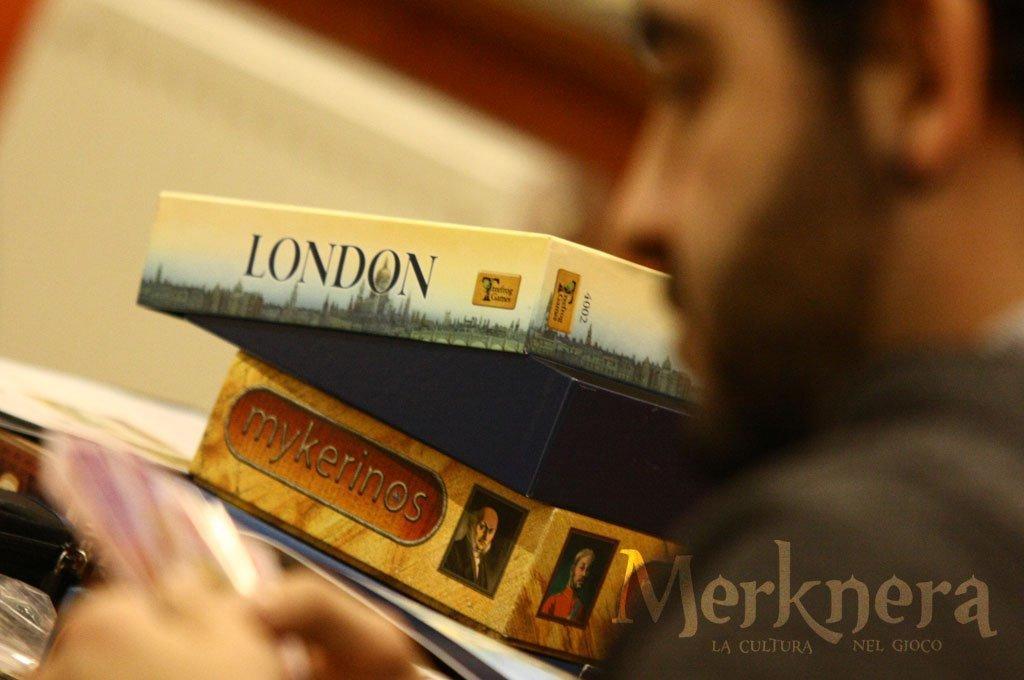Could you give a brief overview of what you see in this image? In this picture we can see a man, in front of him we can find few boxes, in the bottom right hand corner we can see some text. 